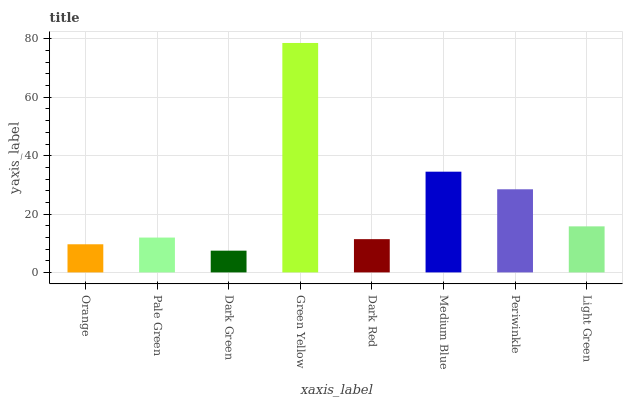Is Dark Green the minimum?
Answer yes or no. Yes. Is Green Yellow the maximum?
Answer yes or no. Yes. Is Pale Green the minimum?
Answer yes or no. No. Is Pale Green the maximum?
Answer yes or no. No. Is Pale Green greater than Orange?
Answer yes or no. Yes. Is Orange less than Pale Green?
Answer yes or no. Yes. Is Orange greater than Pale Green?
Answer yes or no. No. Is Pale Green less than Orange?
Answer yes or no. No. Is Light Green the high median?
Answer yes or no. Yes. Is Pale Green the low median?
Answer yes or no. Yes. Is Pale Green the high median?
Answer yes or no. No. Is Dark Green the low median?
Answer yes or no. No. 